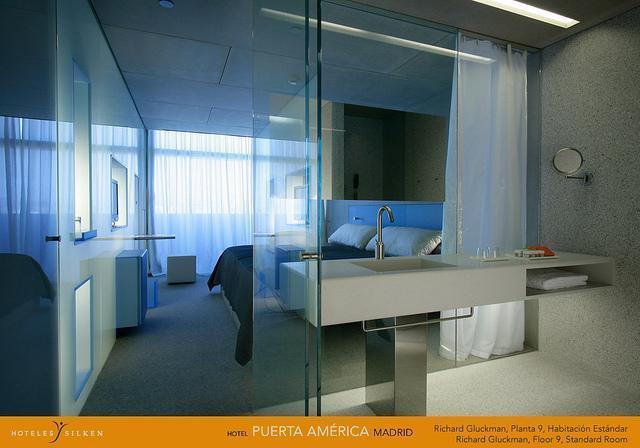How many beds can you see?
Give a very brief answer. 2. 